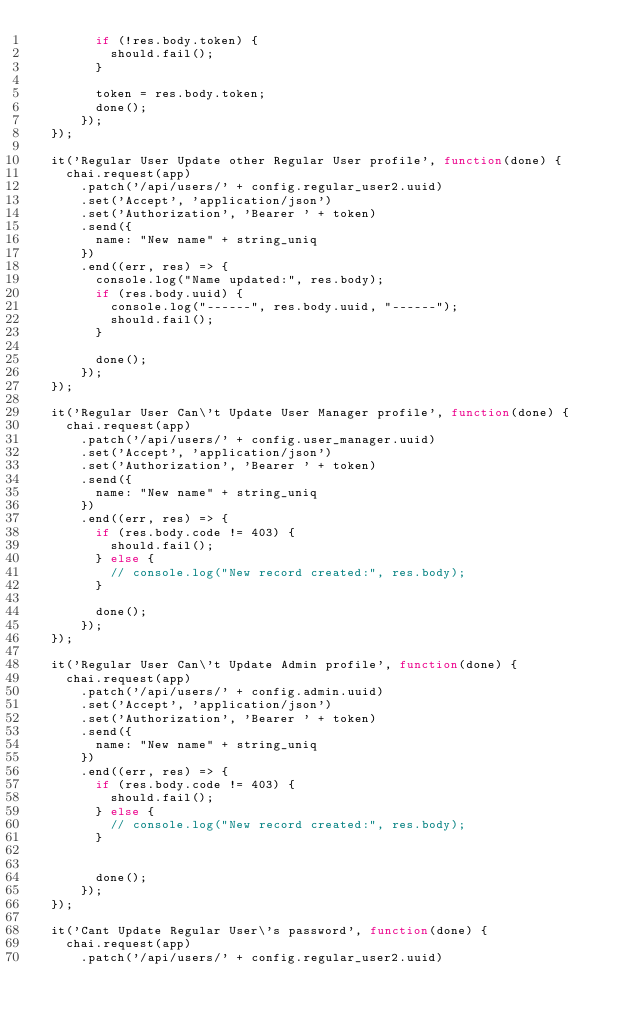Convert code to text. <code><loc_0><loc_0><loc_500><loc_500><_JavaScript_>        if (!res.body.token) {
          should.fail();
        }

        token = res.body.token;
        done();
      });
  });

  it('Regular User Update other Regular User profile', function(done) {
    chai.request(app)
      .patch('/api/users/' + config.regular_user2.uuid)
      .set('Accept', 'application/json')
      .set('Authorization', 'Bearer ' + token)
      .send({
        name: "New name" + string_uniq
      })
      .end((err, res) => {
        console.log("Name updated:", res.body);
        if (res.body.uuid) {
          console.log("------", res.body.uuid, "------");
          should.fail();
        }

        done();
      });
  });

  it('Regular User Can\'t Update User Manager profile', function(done) {
    chai.request(app)
      .patch('/api/users/' + config.user_manager.uuid)
      .set('Accept', 'application/json')
      .set('Authorization', 'Bearer ' + token)
      .send({
        name: "New name" + string_uniq
      })
      .end((err, res) => {
        if (res.body.code != 403) {
          should.fail();
        } else {
          // console.log("New record created:", res.body);
        }

        done();
      });
  });

  it('Regular User Can\'t Update Admin profile', function(done) {
    chai.request(app)
      .patch('/api/users/' + config.admin.uuid)
      .set('Accept', 'application/json')
      .set('Authorization', 'Bearer ' + token)
      .send({
        name: "New name" + string_uniq
      })
      .end((err, res) => {
        if (res.body.code != 403) {
          should.fail();
        } else {
          // console.log("New record created:", res.body);
        }


        done();
      });
  });

  it('Cant Update Regular User\'s password', function(done) {
    chai.request(app)
      .patch('/api/users/' + config.regular_user2.uuid)</code> 